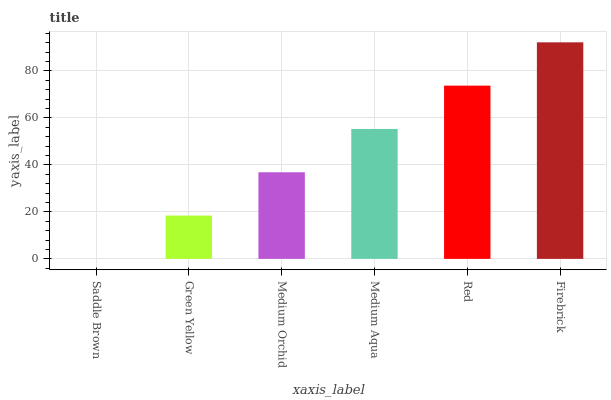Is Green Yellow the minimum?
Answer yes or no. No. Is Green Yellow the maximum?
Answer yes or no. No. Is Green Yellow greater than Saddle Brown?
Answer yes or no. Yes. Is Saddle Brown less than Green Yellow?
Answer yes or no. Yes. Is Saddle Brown greater than Green Yellow?
Answer yes or no. No. Is Green Yellow less than Saddle Brown?
Answer yes or no. No. Is Medium Aqua the high median?
Answer yes or no. Yes. Is Medium Orchid the low median?
Answer yes or no. Yes. Is Red the high median?
Answer yes or no. No. Is Green Yellow the low median?
Answer yes or no. No. 